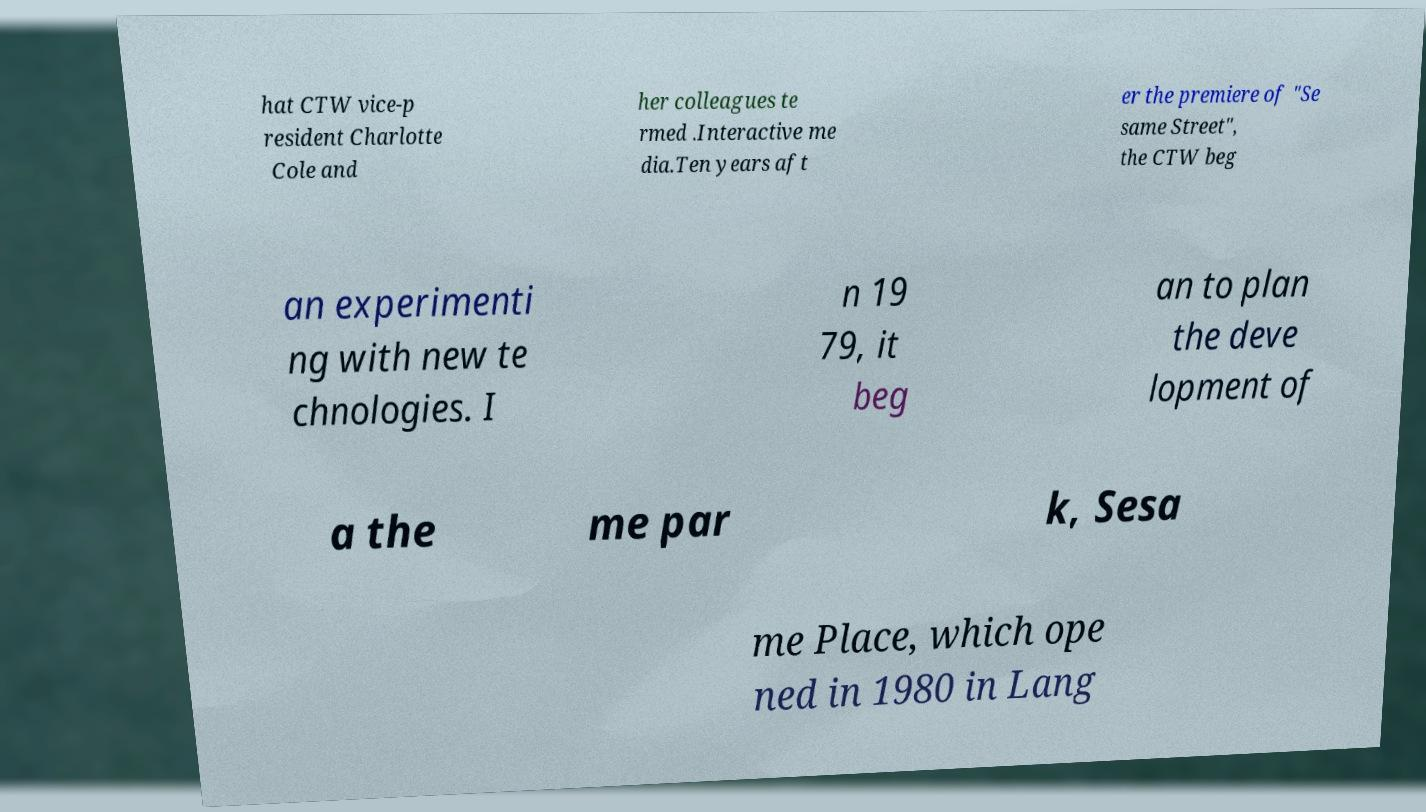For documentation purposes, I need the text within this image transcribed. Could you provide that? hat CTW vice-p resident Charlotte Cole and her colleagues te rmed .Interactive me dia.Ten years aft er the premiere of "Se same Street", the CTW beg an experimenti ng with new te chnologies. I n 19 79, it beg an to plan the deve lopment of a the me par k, Sesa me Place, which ope ned in 1980 in Lang 